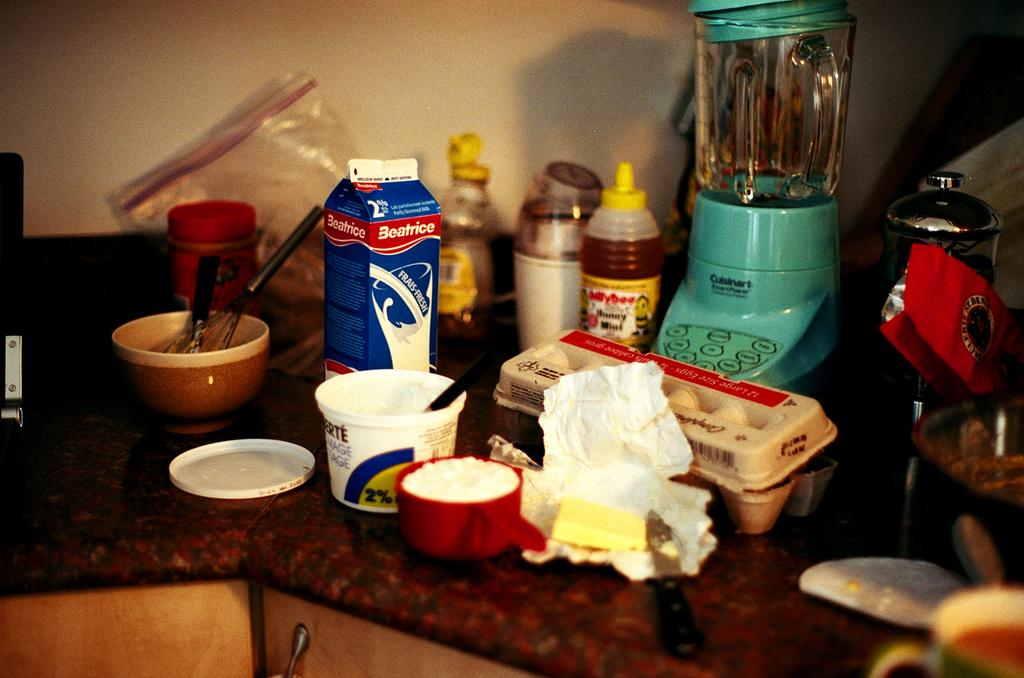Provide a one-sentence caption for the provided image. A counter top with several breakfast style items and a carton of Beatrice brand fresh milk. 